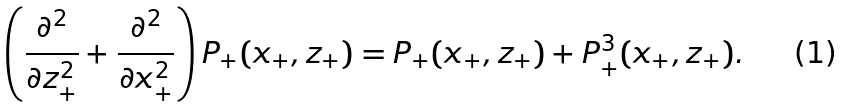Convert formula to latex. <formula><loc_0><loc_0><loc_500><loc_500>\left ( \frac { \partial ^ { 2 } } { \partial z _ { + } ^ { 2 } } + \frac { \partial ^ { 2 } } { \partial x _ { + } ^ { 2 } } \right ) P _ { + } ( x _ { + } , z _ { + } ) = P _ { + } ( x _ { + } , z _ { + } ) + P _ { + } ^ { 3 } ( x _ { + } , z _ { + } ) .</formula> 